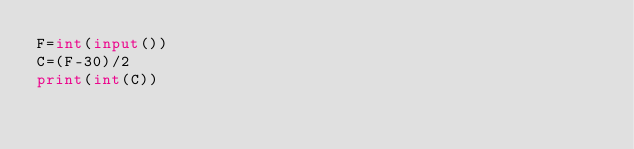Convert code to text. <code><loc_0><loc_0><loc_500><loc_500><_Python_>F=int(input())
C=(F-30)/2
print(int(C))

</code> 